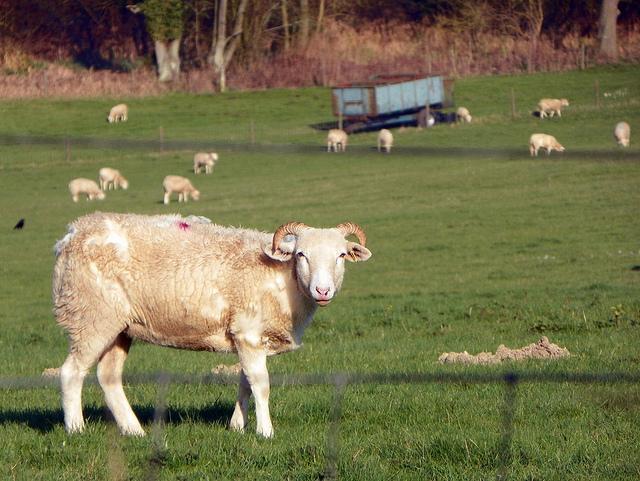Why do sheep have horns?
Pick the correct solution from the four options below to address the question.
Options: Nothing, playing, mating, shock-absorbers. Shock-absorbers. 